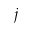Convert formula to latex. <formula><loc_0><loc_0><loc_500><loc_500>j</formula> 